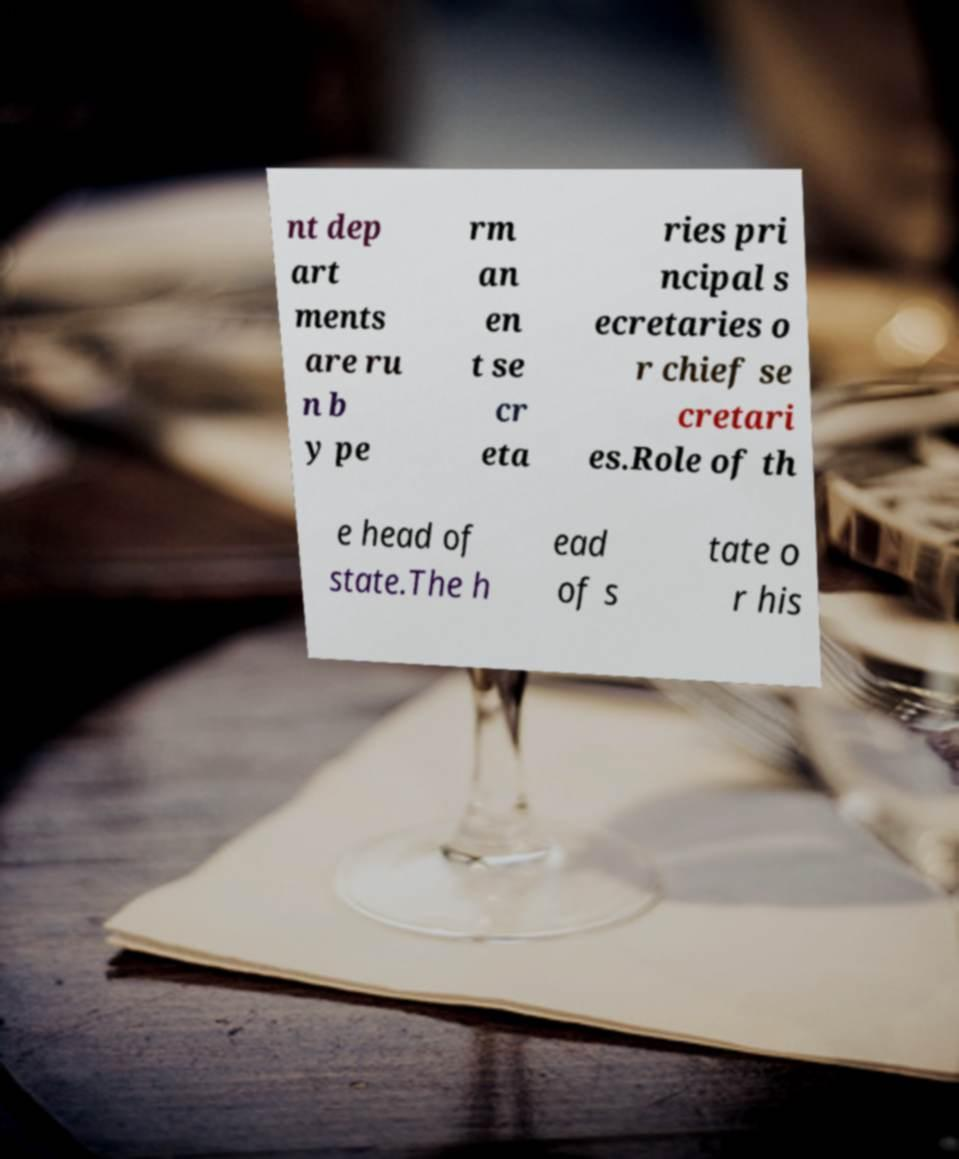For documentation purposes, I need the text within this image transcribed. Could you provide that? nt dep art ments are ru n b y pe rm an en t se cr eta ries pri ncipal s ecretaries o r chief se cretari es.Role of th e head of state.The h ead of s tate o r his 